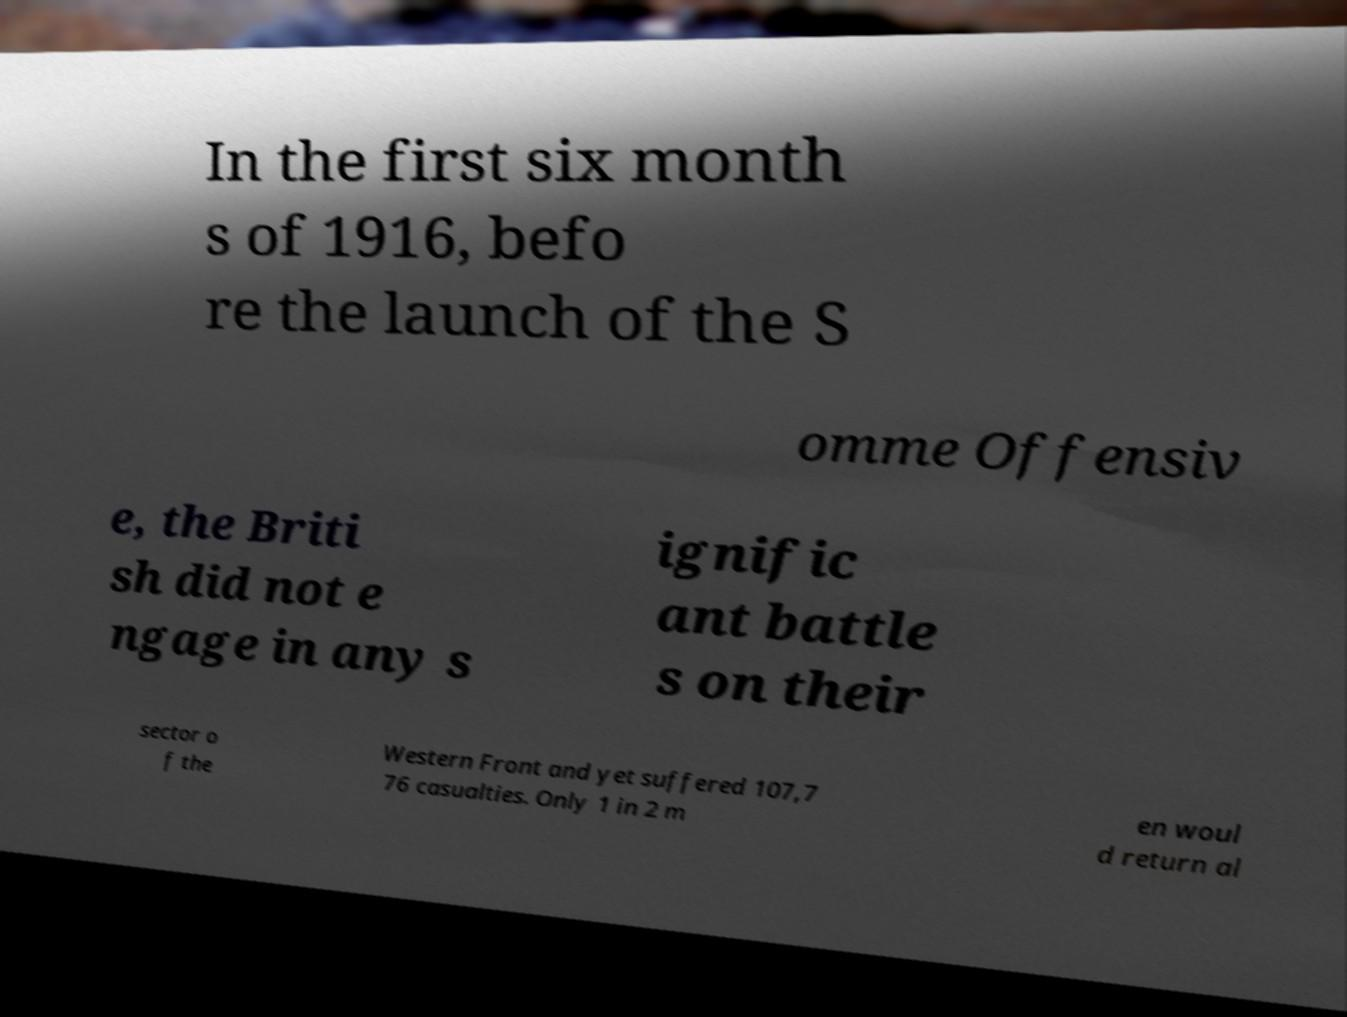I need the written content from this picture converted into text. Can you do that? In the first six month s of 1916, befo re the launch of the S omme Offensiv e, the Briti sh did not e ngage in any s ignific ant battle s on their sector o f the Western Front and yet suffered 107,7 76 casualties. Only 1 in 2 m en woul d return al 